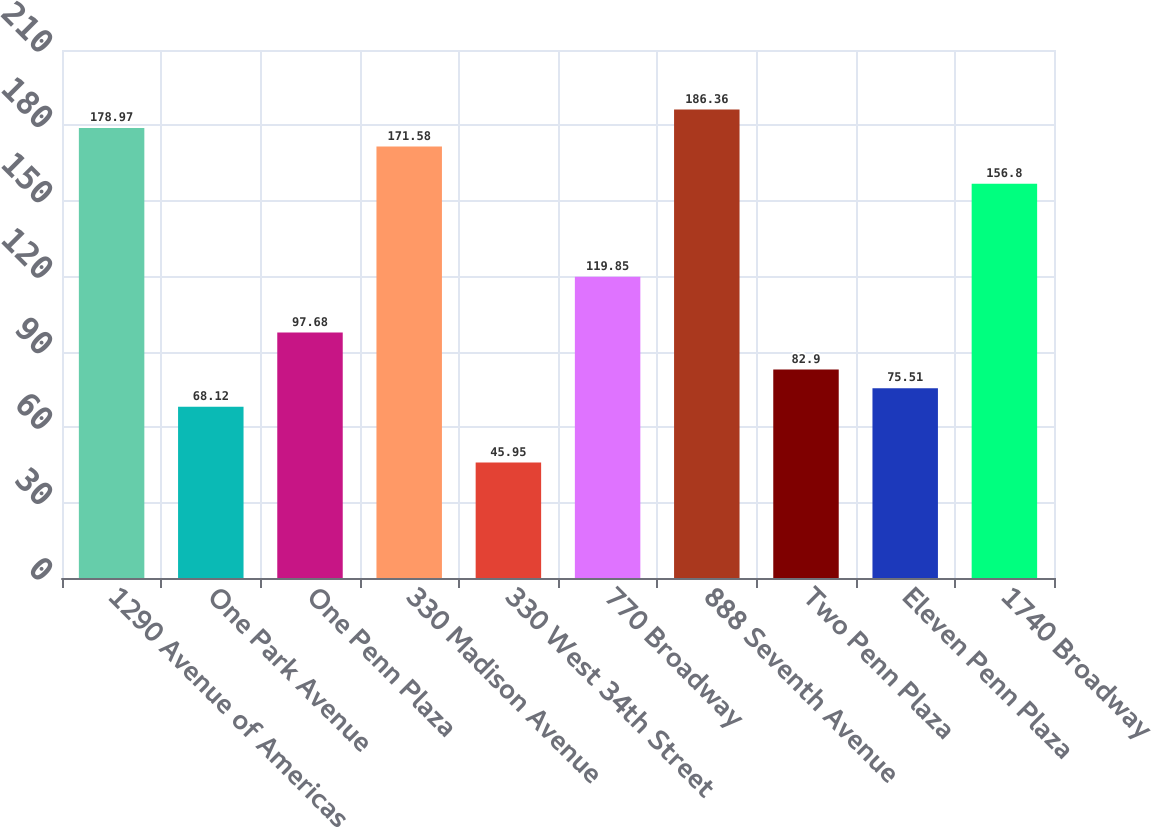<chart> <loc_0><loc_0><loc_500><loc_500><bar_chart><fcel>1290 Avenue of Americas<fcel>One Park Avenue<fcel>One Penn Plaza<fcel>330 Madison Avenue<fcel>330 West 34th Street<fcel>770 Broadway<fcel>888 Seventh Avenue<fcel>Two Penn Plaza<fcel>Eleven Penn Plaza<fcel>1740 Broadway<nl><fcel>178.97<fcel>68.12<fcel>97.68<fcel>171.58<fcel>45.95<fcel>119.85<fcel>186.36<fcel>82.9<fcel>75.51<fcel>156.8<nl></chart> 